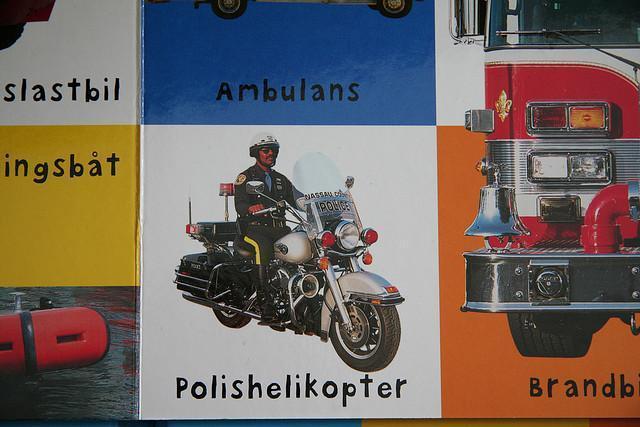How many motorcycles are visible?
Give a very brief answer. 1. 